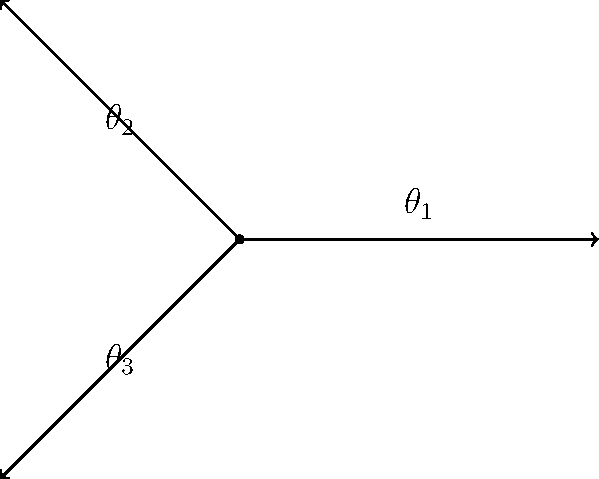Consider an intersection with three approaching roads at angles $\theta_1$, $\theta_2$, and $\theta_3$ as shown in the figure. Given that $\theta_1 = 0°$, $\theta_2 = 135°$, and $\theta_3 = 225°$, determine the optimal green time ratio for each approach if the traffic flow rates are proportional to $\sin(\theta)$ for each angle. What is the green time percentage for the approach at angle $\theta_2$? To solve this problem, we'll follow these steps:

1) The traffic flow rates are proportional to $\sin(\theta)$ for each angle. Let's calculate these values:

   For $\theta_1 = 0°$: $\sin(0°) = 0$
   For $\theta_2 = 135°$: $\sin(135°) = \frac{\sqrt{2}}{2}$
   For $\theta_3 = 225°$: $\sin(225°) = -\frac{\sqrt{2}}{2}$

2) The absolute values of these sinusoidal flows represent the relative traffic demands:

   $|\sin(0°)| = 0$
   $|\sin(135°)| = \frac{\sqrt{2}}{2}$
   $|\sin(225°)| = \frac{\sqrt{2}}{2}$

3) The optimal green time for each approach should be proportional to its traffic demand. The total of these values is:

   $0 + \frac{\sqrt{2}}{2} + \frac{\sqrt{2}}{2} = \sqrt{2}$

4) The green time ratio for $\theta_2$ (135°) is:

   $\frac{\frac{\sqrt{2}}{2}}{\sqrt{2}} = \frac{1}{2}$

5) To convert this to a percentage, we multiply by 100:

   $\frac{1}{2} * 100 = 50\%$

Therefore, the green time percentage for the approach at angle $\theta_2$ (135°) is 50%.
Answer: 50% 